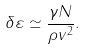Convert formula to latex. <formula><loc_0><loc_0><loc_500><loc_500>\delta \varepsilon \simeq \frac { \gamma N } { \rho v ^ { 2 } } .</formula> 